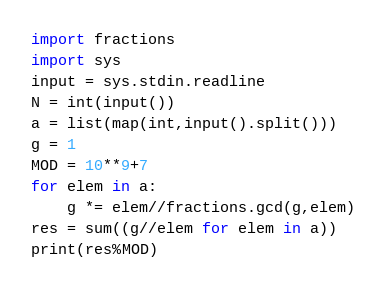<code> <loc_0><loc_0><loc_500><loc_500><_Python_>import fractions
import sys
input = sys.stdin.readline
N = int(input())
a = list(map(int,input().split()))
g = 1
MOD = 10**9+7
for elem in a:
    g *= elem//fractions.gcd(g,elem)
res = sum((g//elem for elem in a))
print(res%MOD)
</code> 